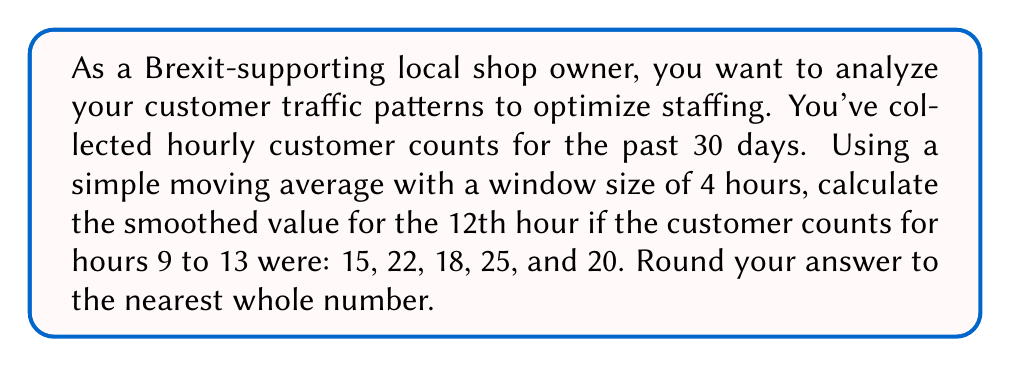Teach me how to tackle this problem. Let's approach this step-by-step:

1) The simple moving average formula for a window size of 4 is:

   $$SMA_t = \frac{1}{4} \sum_{i=t-3}^t x_i$$

   where $SMA_t$ is the simple moving average at time $t$, and $x_i$ are the data points.

2) For the 12th hour, we need to use the data from hours 9, 10, 11, and 12:

   $$SMA_{12} = \frac{1}{4} (x_9 + x_{10} + x_{11} + x_{12})$$

3) Substituting the given values:

   $$SMA_{12} = \frac{1}{4} (15 + 22 + 18 + 25)$$

4) Calculate:

   $$SMA_{12} = \frac{1}{4} (80) = 20$$

5) The question asks to round to the nearest whole number, but 20 is already a whole number.

Therefore, the smoothed value for the 12th hour is 20 customers.
Answer: 20 